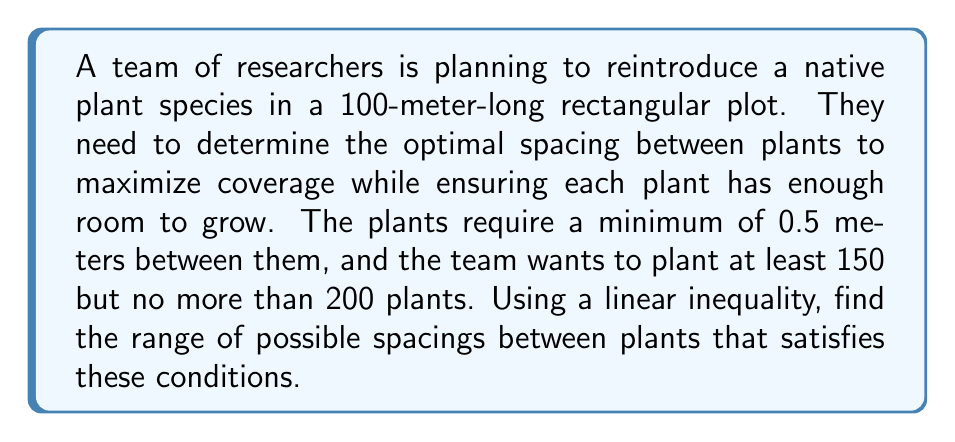Solve this math problem. Let's approach this step-by-step:

1) Let $x$ be the spacing between plants in meters.

2) The number of plants that can fit in the 100-meter plot can be expressed as:
   $n = \frac{100}{x} + 1$
   (We add 1 because the number of spaces between plants is one less than the number of plants)

3) Given the constraints:
   - Minimum spacing: $x \geq 0.5$
   - Minimum number of plants: $n \geq 150$
   - Maximum number of plants: $n \leq 200$

4) Let's set up the inequalities:
   $150 \leq \frac{100}{x} + 1 \leq 200$

5) Subtract 1 from each part:
   $149 \leq \frac{100}{x} \leq 199$

6) Multiply each part by $x$ (note that this flips the inequality signs because $x$ is positive):
   $\frac{100}{199} \leq x \leq \frac{100}{149}$

7) Simplify:
   $0.5025... \leq x \leq 0.6711...$

8) Given that $x \geq 0.5$, our final inequality is:
   $0.5025 \leq x \leq 0.6711$

9) Rounding to three decimal places for practical application:
   $0.503 \leq x \leq 0.671$
Answer: $0.503 \leq x \leq 0.671$ meters 